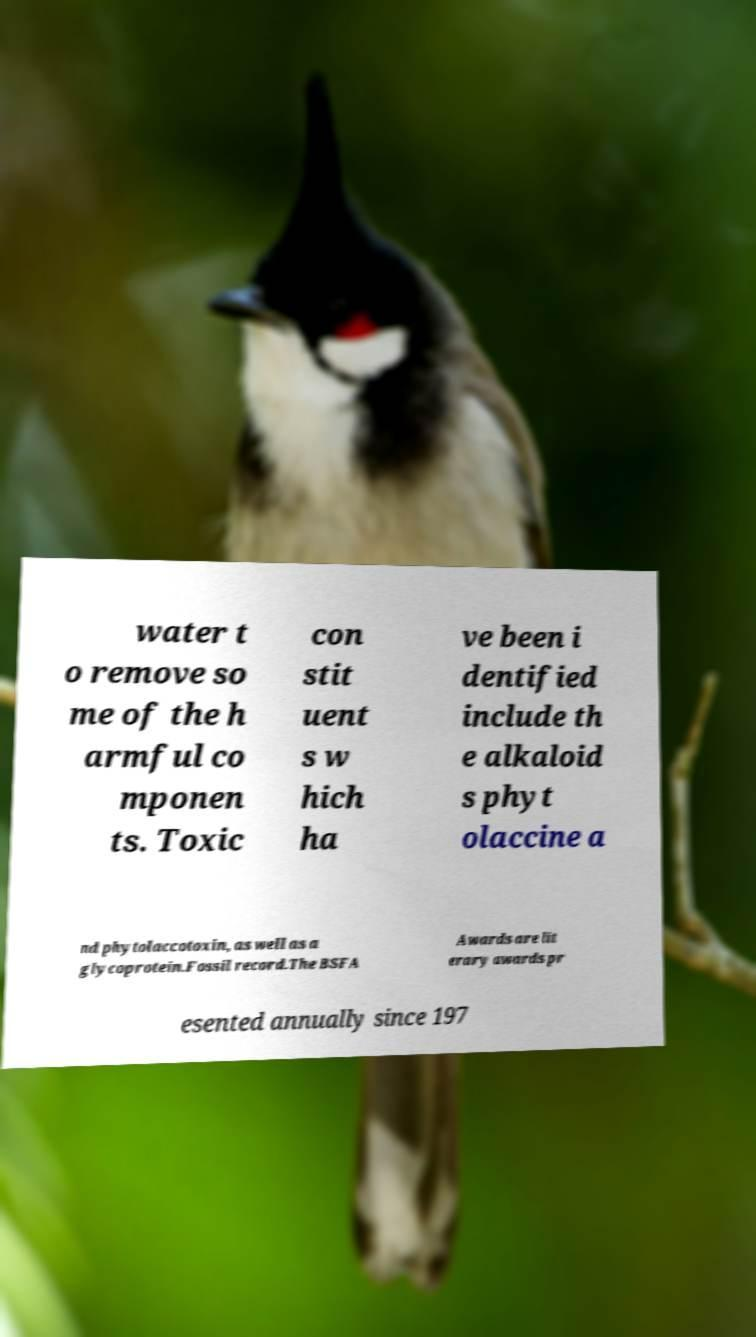Could you assist in decoding the text presented in this image and type it out clearly? water t o remove so me of the h armful co mponen ts. Toxic con stit uent s w hich ha ve been i dentified include th e alkaloid s phyt olaccine a nd phytolaccotoxin, as well as a glycoprotein.Fossil record.The BSFA Awards are lit erary awards pr esented annually since 197 